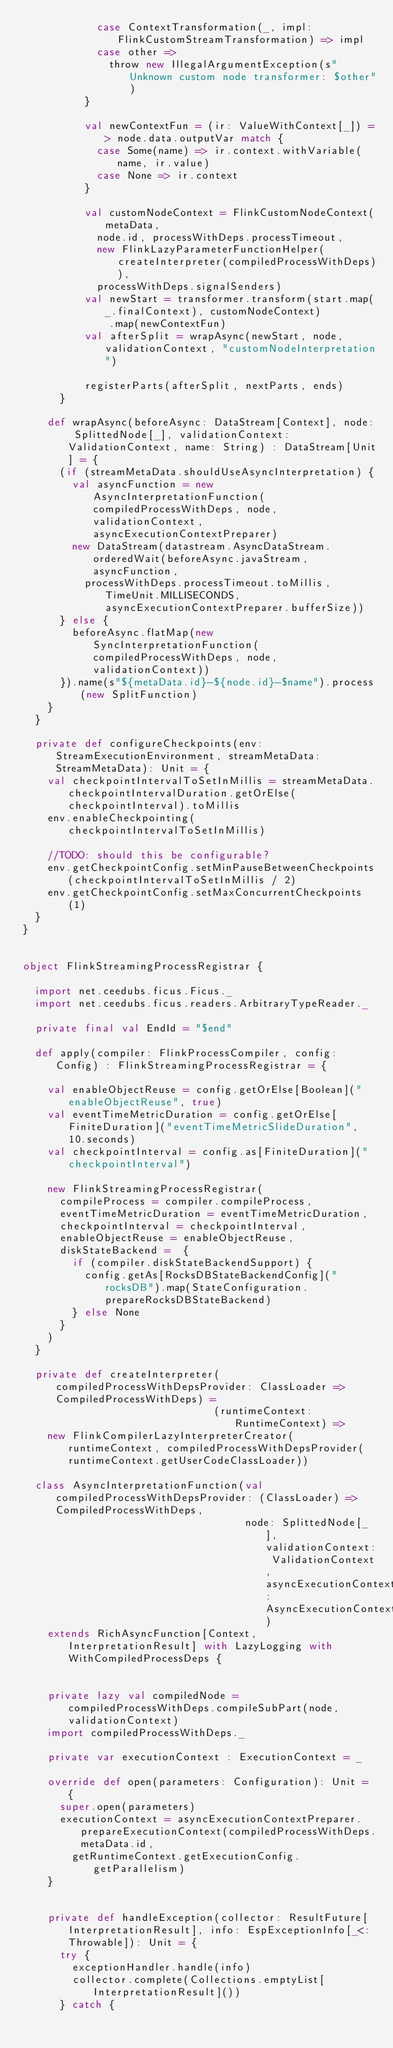<code> <loc_0><loc_0><loc_500><loc_500><_Scala_>            case ContextTransformation(_, impl: FlinkCustomStreamTransformation) => impl
            case other =>
              throw new IllegalArgumentException(s"Unknown custom node transformer: $other")
          }

          val newContextFun = (ir: ValueWithContext[_]) => node.data.outputVar match {
            case Some(name) => ir.context.withVariable(name, ir.value)
            case None => ir.context
          }

          val customNodeContext = FlinkCustomNodeContext(metaData,
            node.id, processWithDeps.processTimeout,
            new FlinkLazyParameterFunctionHelper(createInterpreter(compiledProcessWithDeps)),
            processWithDeps.signalSenders)
          val newStart = transformer.transform(start.map(_.finalContext), customNodeContext)
              .map(newContextFun)
          val afterSplit = wrapAsync(newStart, node, validationContext, "customNodeInterpretation")

          registerParts(afterSplit, nextParts, ends)
      }

    def wrapAsync(beforeAsync: DataStream[Context], node: SplittedNode[_], validationContext: ValidationContext, name: String) : DataStream[Unit] = {
      (if (streamMetaData.shouldUseAsyncInterpretation) {
        val asyncFunction = new AsyncInterpretationFunction(compiledProcessWithDeps, node, validationContext, asyncExecutionContextPreparer)
        new DataStream(datastream.AsyncDataStream.orderedWait(beforeAsync.javaStream, asyncFunction,
          processWithDeps.processTimeout.toMillis, TimeUnit.MILLISECONDS, asyncExecutionContextPreparer.bufferSize))
      } else {
        beforeAsync.flatMap(new SyncInterpretationFunction(compiledProcessWithDeps, node, validationContext))
      }).name(s"${metaData.id}-${node.id}-$name").process(new SplitFunction)
    }
  }

  private def configureCheckpoints(env: StreamExecutionEnvironment, streamMetaData: StreamMetaData): Unit = {
    val checkpointIntervalToSetInMillis = streamMetaData.checkpointIntervalDuration.getOrElse(checkpointInterval).toMillis
    env.enableCheckpointing(checkpointIntervalToSetInMillis)

    //TODO: should this be configurable?
    env.getCheckpointConfig.setMinPauseBetweenCheckpoints(checkpointIntervalToSetInMillis / 2)
    env.getCheckpointConfig.setMaxConcurrentCheckpoints(1)
  }
}


object FlinkStreamingProcessRegistrar {

  import net.ceedubs.ficus.Ficus._
  import net.ceedubs.ficus.readers.ArbitraryTypeReader._

  private final val EndId = "$end"

  def apply(compiler: FlinkProcessCompiler, config: Config) : FlinkStreamingProcessRegistrar = {

    val enableObjectReuse = config.getOrElse[Boolean]("enableObjectReuse", true)
    val eventTimeMetricDuration = config.getOrElse[FiniteDuration]("eventTimeMetricSlideDuration", 10.seconds)
    val checkpointInterval = config.as[FiniteDuration]("checkpointInterval")

    new FlinkStreamingProcessRegistrar(
      compileProcess = compiler.compileProcess,
      eventTimeMetricDuration = eventTimeMetricDuration,
      checkpointInterval = checkpointInterval,
      enableObjectReuse = enableObjectReuse,
      diskStateBackend =  {
        if (compiler.diskStateBackendSupport) {
          config.getAs[RocksDBStateBackendConfig]("rocksDB").map(StateConfiguration.prepareRocksDBStateBackend)
        } else None
      }
    )
  }

  private def createInterpreter(compiledProcessWithDepsProvider: ClassLoader => CompiledProcessWithDeps) =
                               (runtimeContext: RuntimeContext) =>
    new FlinkCompilerLazyInterpreterCreator(runtimeContext, compiledProcessWithDepsProvider(runtimeContext.getUserCodeClassLoader))

  class AsyncInterpretationFunction(val compiledProcessWithDepsProvider: (ClassLoader) => CompiledProcessWithDeps,
                                    node: SplittedNode[_], validationContext: ValidationContext, asyncExecutionContextPreparer: AsyncExecutionContextPreparer)
    extends RichAsyncFunction[Context, InterpretationResult] with LazyLogging with WithCompiledProcessDeps {


    private lazy val compiledNode = compiledProcessWithDeps.compileSubPart(node, validationContext)
    import compiledProcessWithDeps._

    private var executionContext : ExecutionContext = _

    override def open(parameters: Configuration): Unit = {
      super.open(parameters)
      executionContext = asyncExecutionContextPreparer.prepareExecutionContext(compiledProcessWithDeps.metaData.id,
        getRuntimeContext.getExecutionConfig.getParallelism)
    }


    private def handleException(collector: ResultFuture[InterpretationResult], info: EspExceptionInfo[_<:Throwable]): Unit = {
      try {
        exceptionHandler.handle(info)
        collector.complete(Collections.emptyList[InterpretationResult]())
      } catch {</code> 